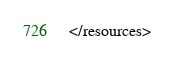<code> <loc_0><loc_0><loc_500><loc_500><_XML_></resources></code> 